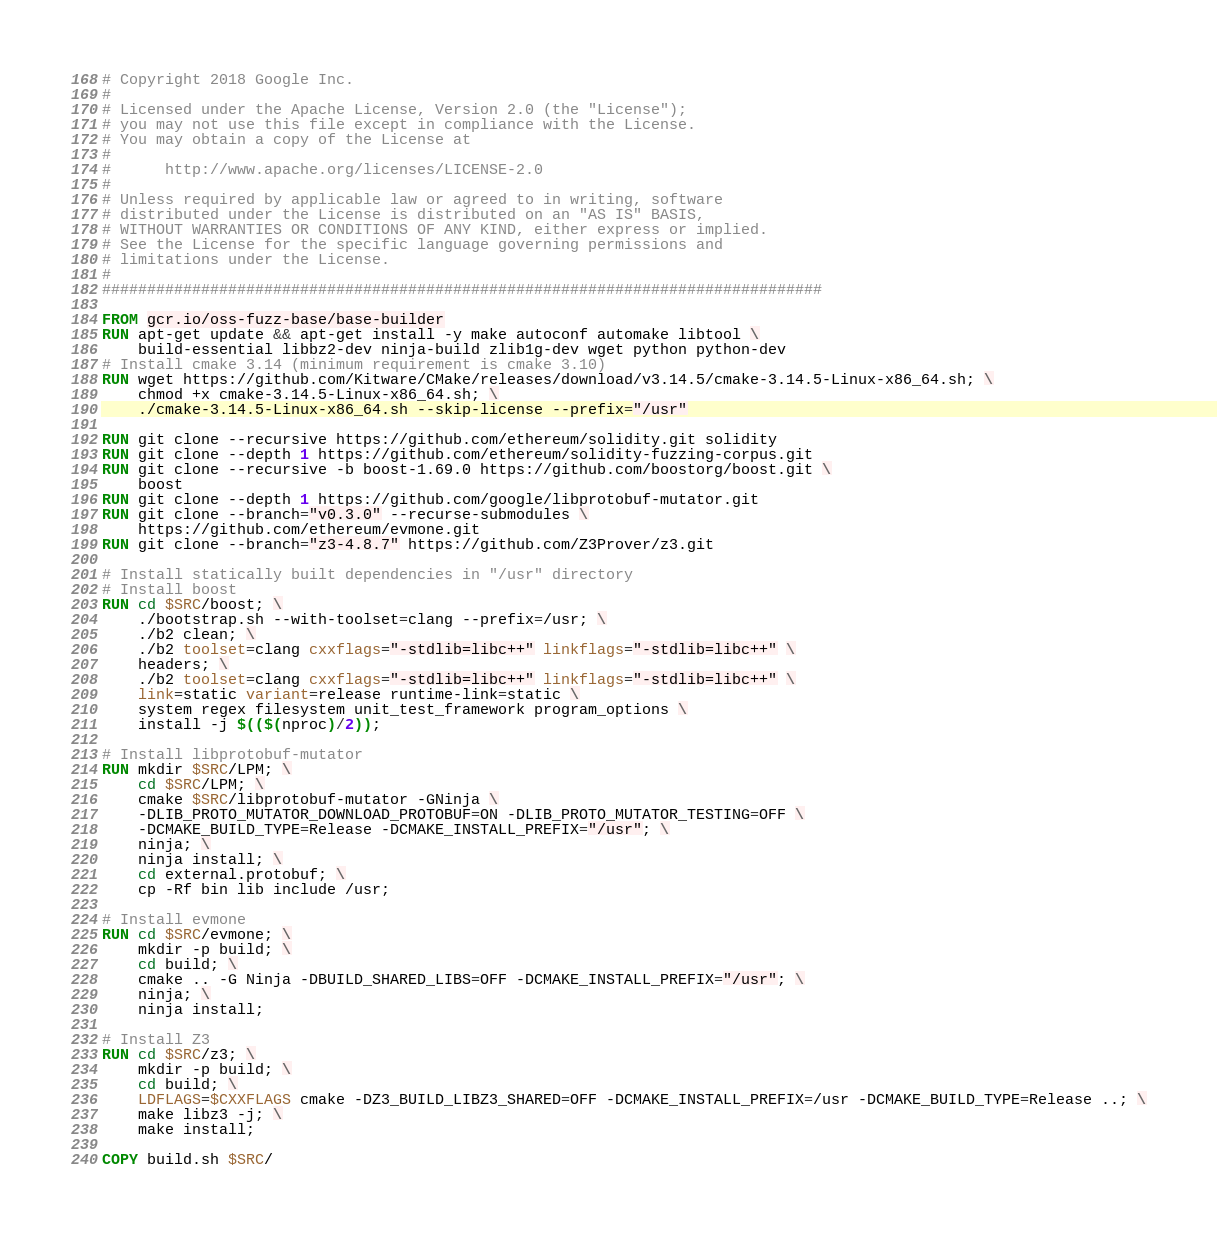Convert code to text. <code><loc_0><loc_0><loc_500><loc_500><_Dockerfile_># Copyright 2018 Google Inc.
#
# Licensed under the Apache License, Version 2.0 (the "License");
# you may not use this file except in compliance with the License.
# You may obtain a copy of the License at
#
#      http://www.apache.org/licenses/LICENSE-2.0
#
# Unless required by applicable law or agreed to in writing, software
# distributed under the License is distributed on an "AS IS" BASIS,
# WITHOUT WARRANTIES OR CONDITIONS OF ANY KIND, either express or implied.
# See the License for the specific language governing permissions and
# limitations under the License.
#
################################################################################

FROM gcr.io/oss-fuzz-base/base-builder
RUN apt-get update && apt-get install -y make autoconf automake libtool \
    build-essential libbz2-dev ninja-build zlib1g-dev wget python python-dev
# Install cmake 3.14 (minimum requirement is cmake 3.10)
RUN wget https://github.com/Kitware/CMake/releases/download/v3.14.5/cmake-3.14.5-Linux-x86_64.sh; \
    chmod +x cmake-3.14.5-Linux-x86_64.sh; \
    ./cmake-3.14.5-Linux-x86_64.sh --skip-license --prefix="/usr"

RUN git clone --recursive https://github.com/ethereum/solidity.git solidity
RUN git clone --depth 1 https://github.com/ethereum/solidity-fuzzing-corpus.git
RUN git clone --recursive -b boost-1.69.0 https://github.com/boostorg/boost.git \
    boost
RUN git clone --depth 1 https://github.com/google/libprotobuf-mutator.git
RUN git clone --branch="v0.3.0" --recurse-submodules \
    https://github.com/ethereum/evmone.git
RUN git clone --branch="z3-4.8.7" https://github.com/Z3Prover/z3.git

# Install statically built dependencies in "/usr" directory
# Install boost
RUN cd $SRC/boost; \
    ./bootstrap.sh --with-toolset=clang --prefix=/usr; \
    ./b2 clean; \
    ./b2 toolset=clang cxxflags="-stdlib=libc++" linkflags="-stdlib=libc++" \
    headers; \
    ./b2 toolset=clang cxxflags="-stdlib=libc++" linkflags="-stdlib=libc++" \
    link=static variant=release runtime-link=static \
    system regex filesystem unit_test_framework program_options \
    install -j $(($(nproc)/2));

# Install libprotobuf-mutator
RUN mkdir $SRC/LPM; \
    cd $SRC/LPM; \
    cmake $SRC/libprotobuf-mutator -GNinja \
    -DLIB_PROTO_MUTATOR_DOWNLOAD_PROTOBUF=ON -DLIB_PROTO_MUTATOR_TESTING=OFF \
    -DCMAKE_BUILD_TYPE=Release -DCMAKE_INSTALL_PREFIX="/usr"; \
    ninja; \
    ninja install; \
    cd external.protobuf; \
    cp -Rf bin lib include /usr;

# Install evmone
RUN cd $SRC/evmone; \
    mkdir -p build; \
    cd build; \
    cmake .. -G Ninja -DBUILD_SHARED_LIBS=OFF -DCMAKE_INSTALL_PREFIX="/usr"; \
    ninja; \
    ninja install;

# Install Z3
RUN cd $SRC/z3; \
    mkdir -p build; \
    cd build; \
    LDFLAGS=$CXXFLAGS cmake -DZ3_BUILD_LIBZ3_SHARED=OFF -DCMAKE_INSTALL_PREFIX=/usr -DCMAKE_BUILD_TYPE=Release ..; \
    make libz3 -j; \
    make install;

COPY build.sh $SRC/
</code> 